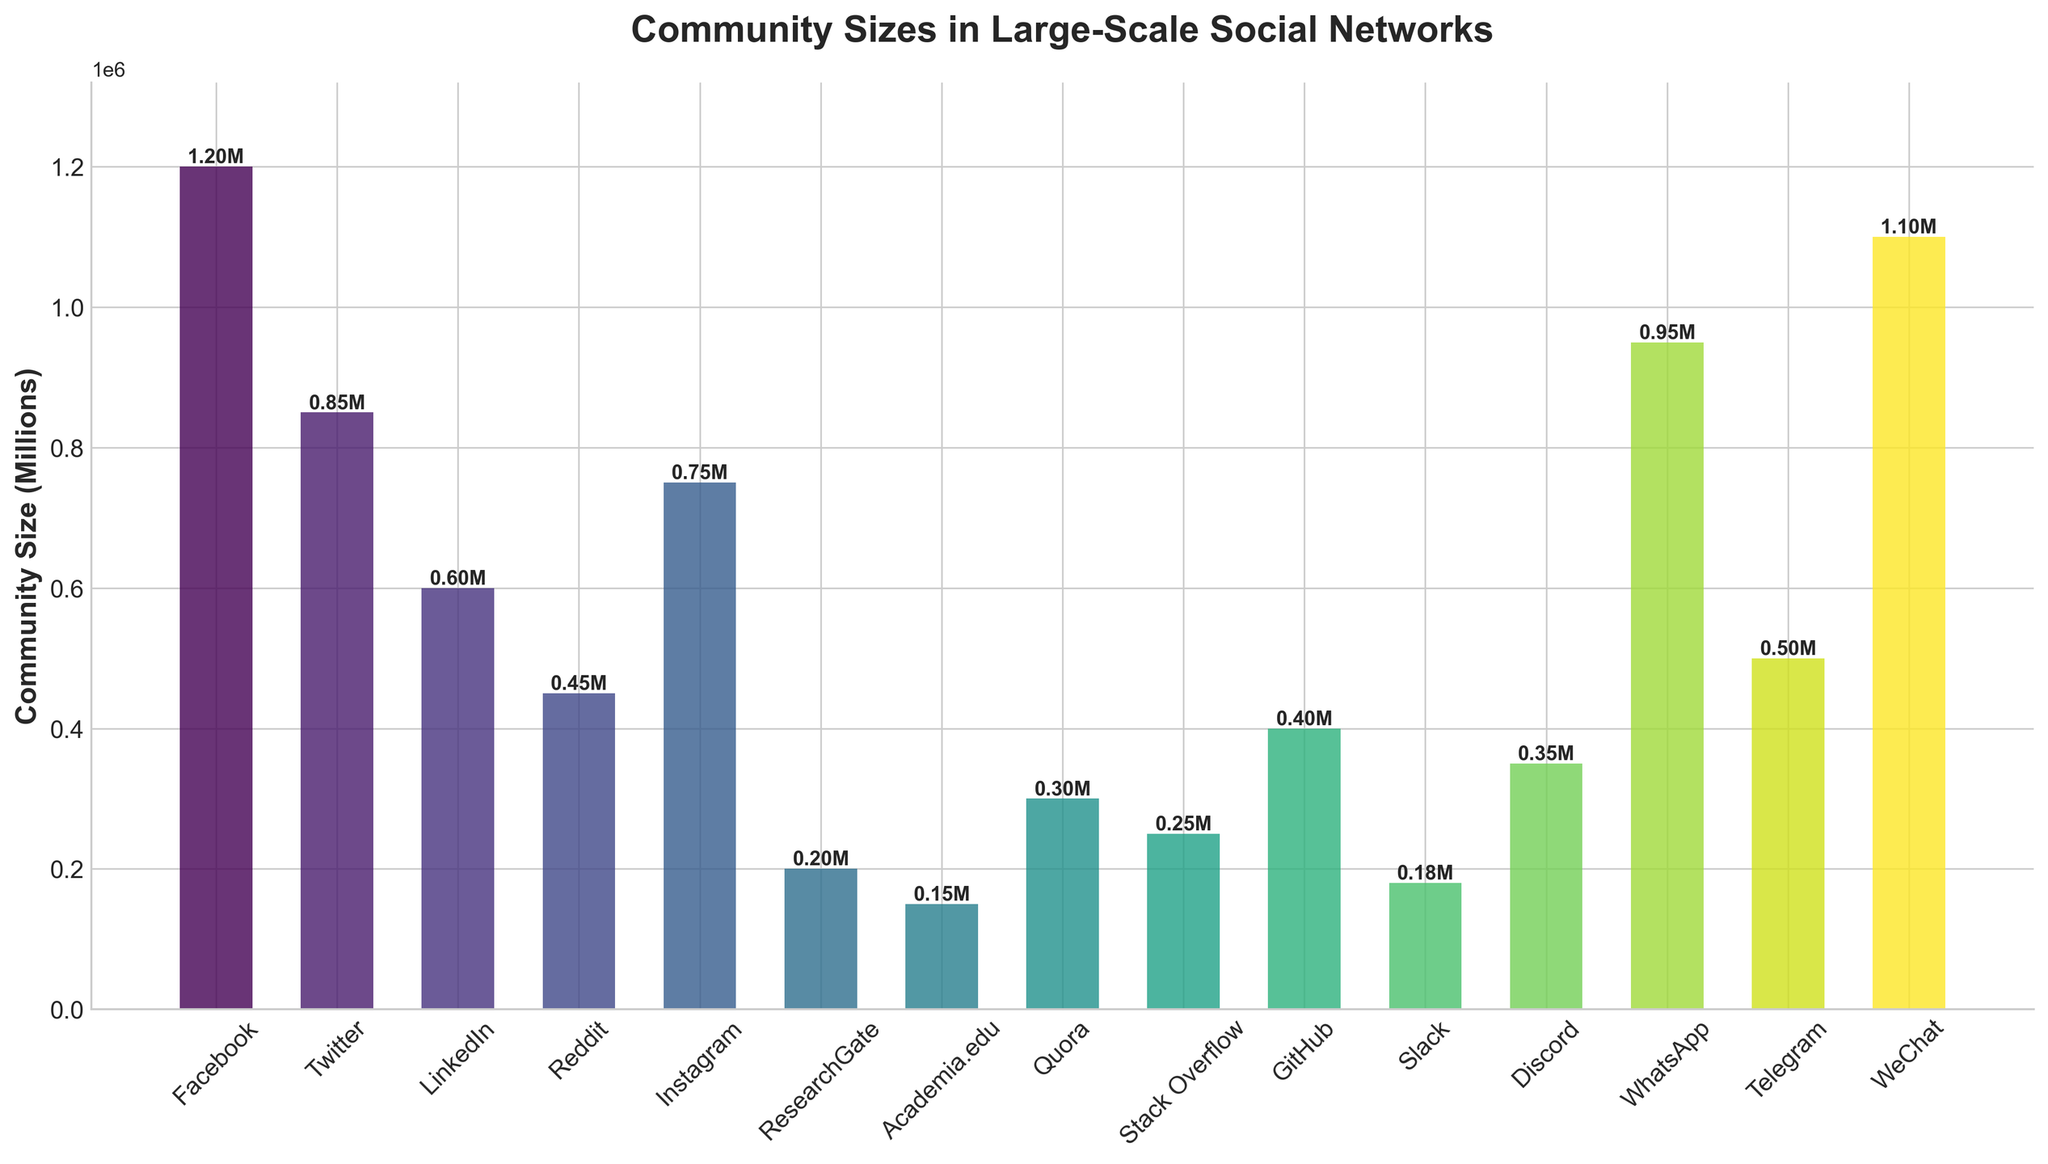What is the community size of Facebook? From the bar chart, we can visually identify the height of the Facebook bar and refer to the text label near the top. The value is 1200000.
Answer: 1,200,000 Which social network has the smallest community size? By comparing the heights of all bars in the plot, we can see that Academia.edu has the smallest bar.
Answer: Academia.edu How much larger is the community size of WhatsApp compared to Quora? Identify the heights of the bars for WhatsApp and Quora from the chart. WhatsApp is 950,000, and Quora is 300,000. The difference is 950,000 - 300,000.
Answer: 650,000 What is the average community size of Reddit and GitHub? The community sizes for Reddit and GitHub are 450,000 and 400,000, respectively. Calculate the sum, 450,000 + 400,000 = 850,000, and then divide by 2.
Answer: 425,000 Which network has a community size closest to 1 million? Observe the heights of the bars close to 1 million. WhatsApp (950,000), WeChat (1,100,000), and Facebook (1,200,000) are the closest. WeChat is the nearest.
Answer: WeChat How much larger is the highest community size compared to the average community size of Instagram, Telegram, and LinkedIn? Identify the highest community size, which is 1,200,000 (Facebook). The community sizes of Instagram, Telegram, and LinkedIn are 750,000, 500,000, and 600,000 respectively. Compute the average: (750,000 + 500,000 + 600,000) / 3 = 1,850,000 / 3 ≈ 616,667. The difference is 1,200,000 - 616,667.
Answer: 583,333 Which networks have a community size greater than 800,000 but less than 1,200,000? Visually identify the bars within the range 800,000 to 1,200,000. Twitter (850,000), WhatsApp (950,000), and WeChat (1,100,000) fit this criterion.
Answer: Twitter, WhatsApp, WeChat What is the combined community size of Stack Overflow, GitHub, and Slack? Identify the community sizes for Stack Overflow, GitHub, and Slack which are 250,000, 400,000, and 180,000, respectively. Sum them up: 250,000 + 400,000 + 180,000.
Answer: 830,000 Rank the top three networks by community size. From the bar heights, identify the top three: Facebook (1,200,000), WeChat (1,100,000), WhatsApp (950,000).
Answer: Facebook, WeChat, WhatsApp 